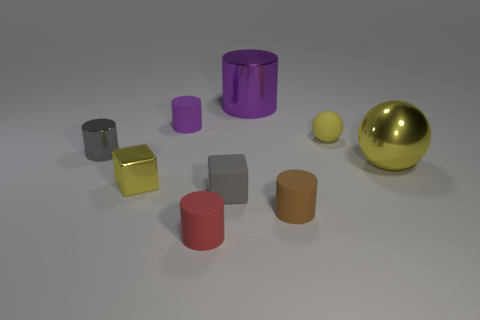Subtract all purple metal cylinders. How many cylinders are left? 4 Subtract all brown cylinders. How many cylinders are left? 4 Subtract all cyan cylinders. Subtract all red balls. How many cylinders are left? 5 Add 1 tiny brown objects. How many objects exist? 10 Subtract all balls. How many objects are left? 7 Add 6 gray rubber things. How many gray rubber things exist? 7 Subtract 1 yellow cubes. How many objects are left? 8 Subtract all tiny cyan shiny cubes. Subtract all purple rubber cylinders. How many objects are left? 8 Add 7 large shiny spheres. How many large shiny spheres are left? 8 